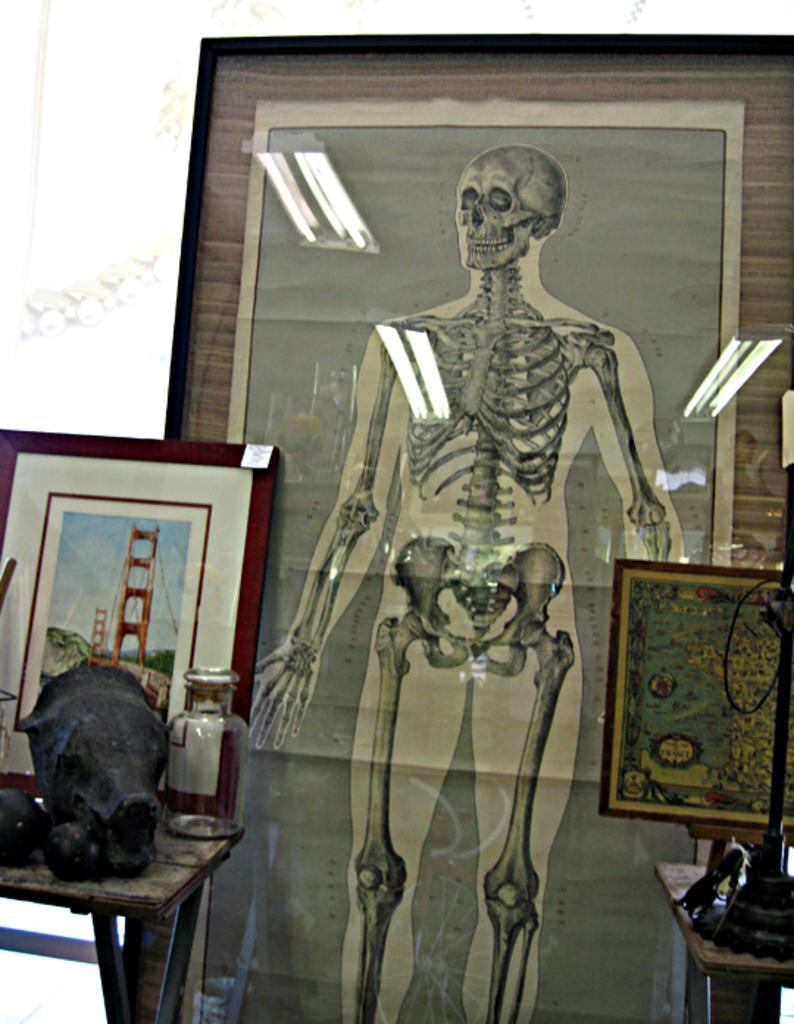What is depicted on the right side of the image? There is an image of a human skeleton system on the right side of the image. What can be seen on the left side of the image? There is a photograph of a London bridge on the left side of the image. What position does the rod hold in the image? There is no rod present in the image. 